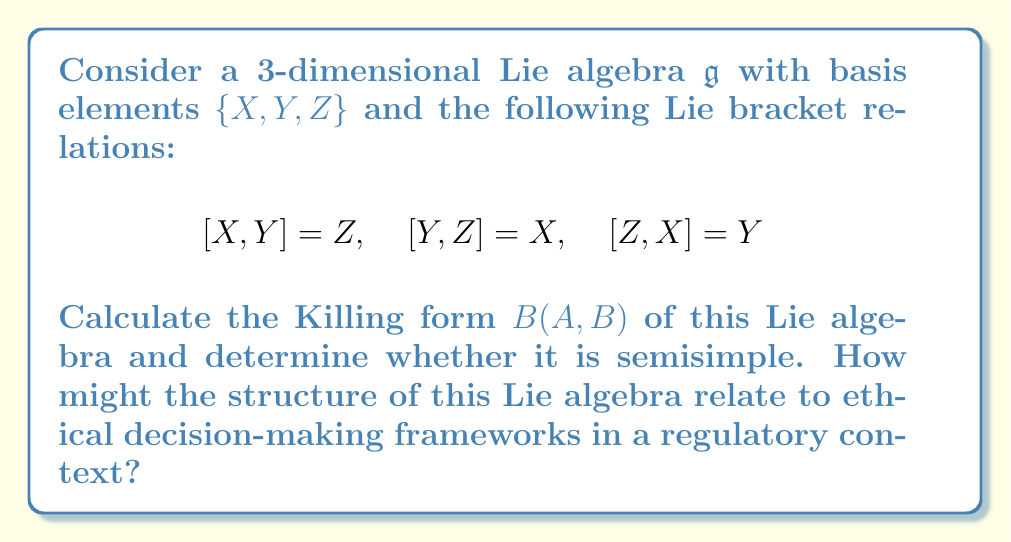Can you answer this question? To calculate the Killing form and determine if the Lie algebra is semisimple, we'll follow these steps:

1) The Killing form is defined as $B(A,B) = \text{tr}(\text{ad}(A) \circ \text{ad}(B))$, where $\text{ad}(A)$ is the adjoint representation of $A$.

2) First, let's calculate the adjoint representations of $X$, $Y$, and $Z$:

   $\text{ad}(X) = \begin{pmatrix} 0 & 0 & -1 \\ 0 & 0 & 1 \\ 0 & -1 & 0 \end{pmatrix}$
   
   $\text{ad}(Y) = \begin{pmatrix} 0 & 0 & 1 \\ 0 & 0 & -1 \\ -1 & 0 & 0 \end{pmatrix}$
   
   $\text{ad}(Z) = \begin{pmatrix} 0 & -1 & 0 \\ 1 & 0 & 0 \\ 0 & 0 & 0 \end{pmatrix}$

3) Now, we can calculate the Killing form for each pair of basis elements:

   $B(X,X) = \text{tr}(\text{ad}(X) \circ \text{ad}(X)) = -2$
   $B(Y,Y) = \text{tr}(\text{ad}(Y) \circ \text{ad}(Y)) = -2$
   $B(Z,Z) = \text{tr}(\text{ad}(Z) \circ \text{ad}(Z)) = -2$
   $B(X,Y) = B(Y,X) = \text{tr}(\text{ad}(X) \circ \text{ad}(Y)) = 0$
   $B(X,Z) = B(Z,X) = \text{tr}(\text{ad}(X) \circ \text{ad}(Z)) = 0$
   $B(Y,Z) = B(Z,Y) = \text{tr}(\text{ad}(Y) \circ \text{ad}(Z)) = 0$

4) The Killing form matrix is therefore:

   $B = \begin{pmatrix} -2 & 0 & 0 \\ 0 & -2 & 0 \\ 0 & 0 & -2 \end{pmatrix}$

5) A Lie algebra is semisimple if and only if its Killing form is non-degenerate. The determinant of $B$ is $-8 \neq 0$, so the Killing form is non-degenerate, and thus the Lie algebra is semisimple.

In the context of ethical decision-making in a regulatory environment, this Lie algebra structure could be interpreted as follows:

1) The three basis elements $X$, $Y$, and $Z$ could represent three fundamental ethical principles or regulatory considerations.

2) The Lie bracket relations show how these principles interact and influence each other, forming a cyclic relationship.

3) The semisimple nature of the Lie algebra suggests that the ethical framework is robust and well-balanced, with no principle being redundant or less important than the others.

4) The non-degeneracy of the Killing form implies that each principle contributes uniquely to the overall ethical framework, and no principle can be expressed as a combination of the others.

5) The symmetry in the Killing form (all diagonal elements equal to -2) suggests an equal weighting of the three principles in the decision-making process.

This mathematical structure could guide the development of a balanced and comprehensive ethical decision-making framework in regulatory contexts, ensuring that multiple perspectives are considered and no single factor dominates the others.
Answer: The Killing form of the given Lie algebra is:

$$B = \begin{pmatrix} -2 & 0 & 0 \\ 0 & -2 & 0 \\ 0 & 0 & -2 \end{pmatrix}$$

The Lie algebra is semisimple because the Killing form is non-degenerate (det($B$) = -8 ≠ 0). 